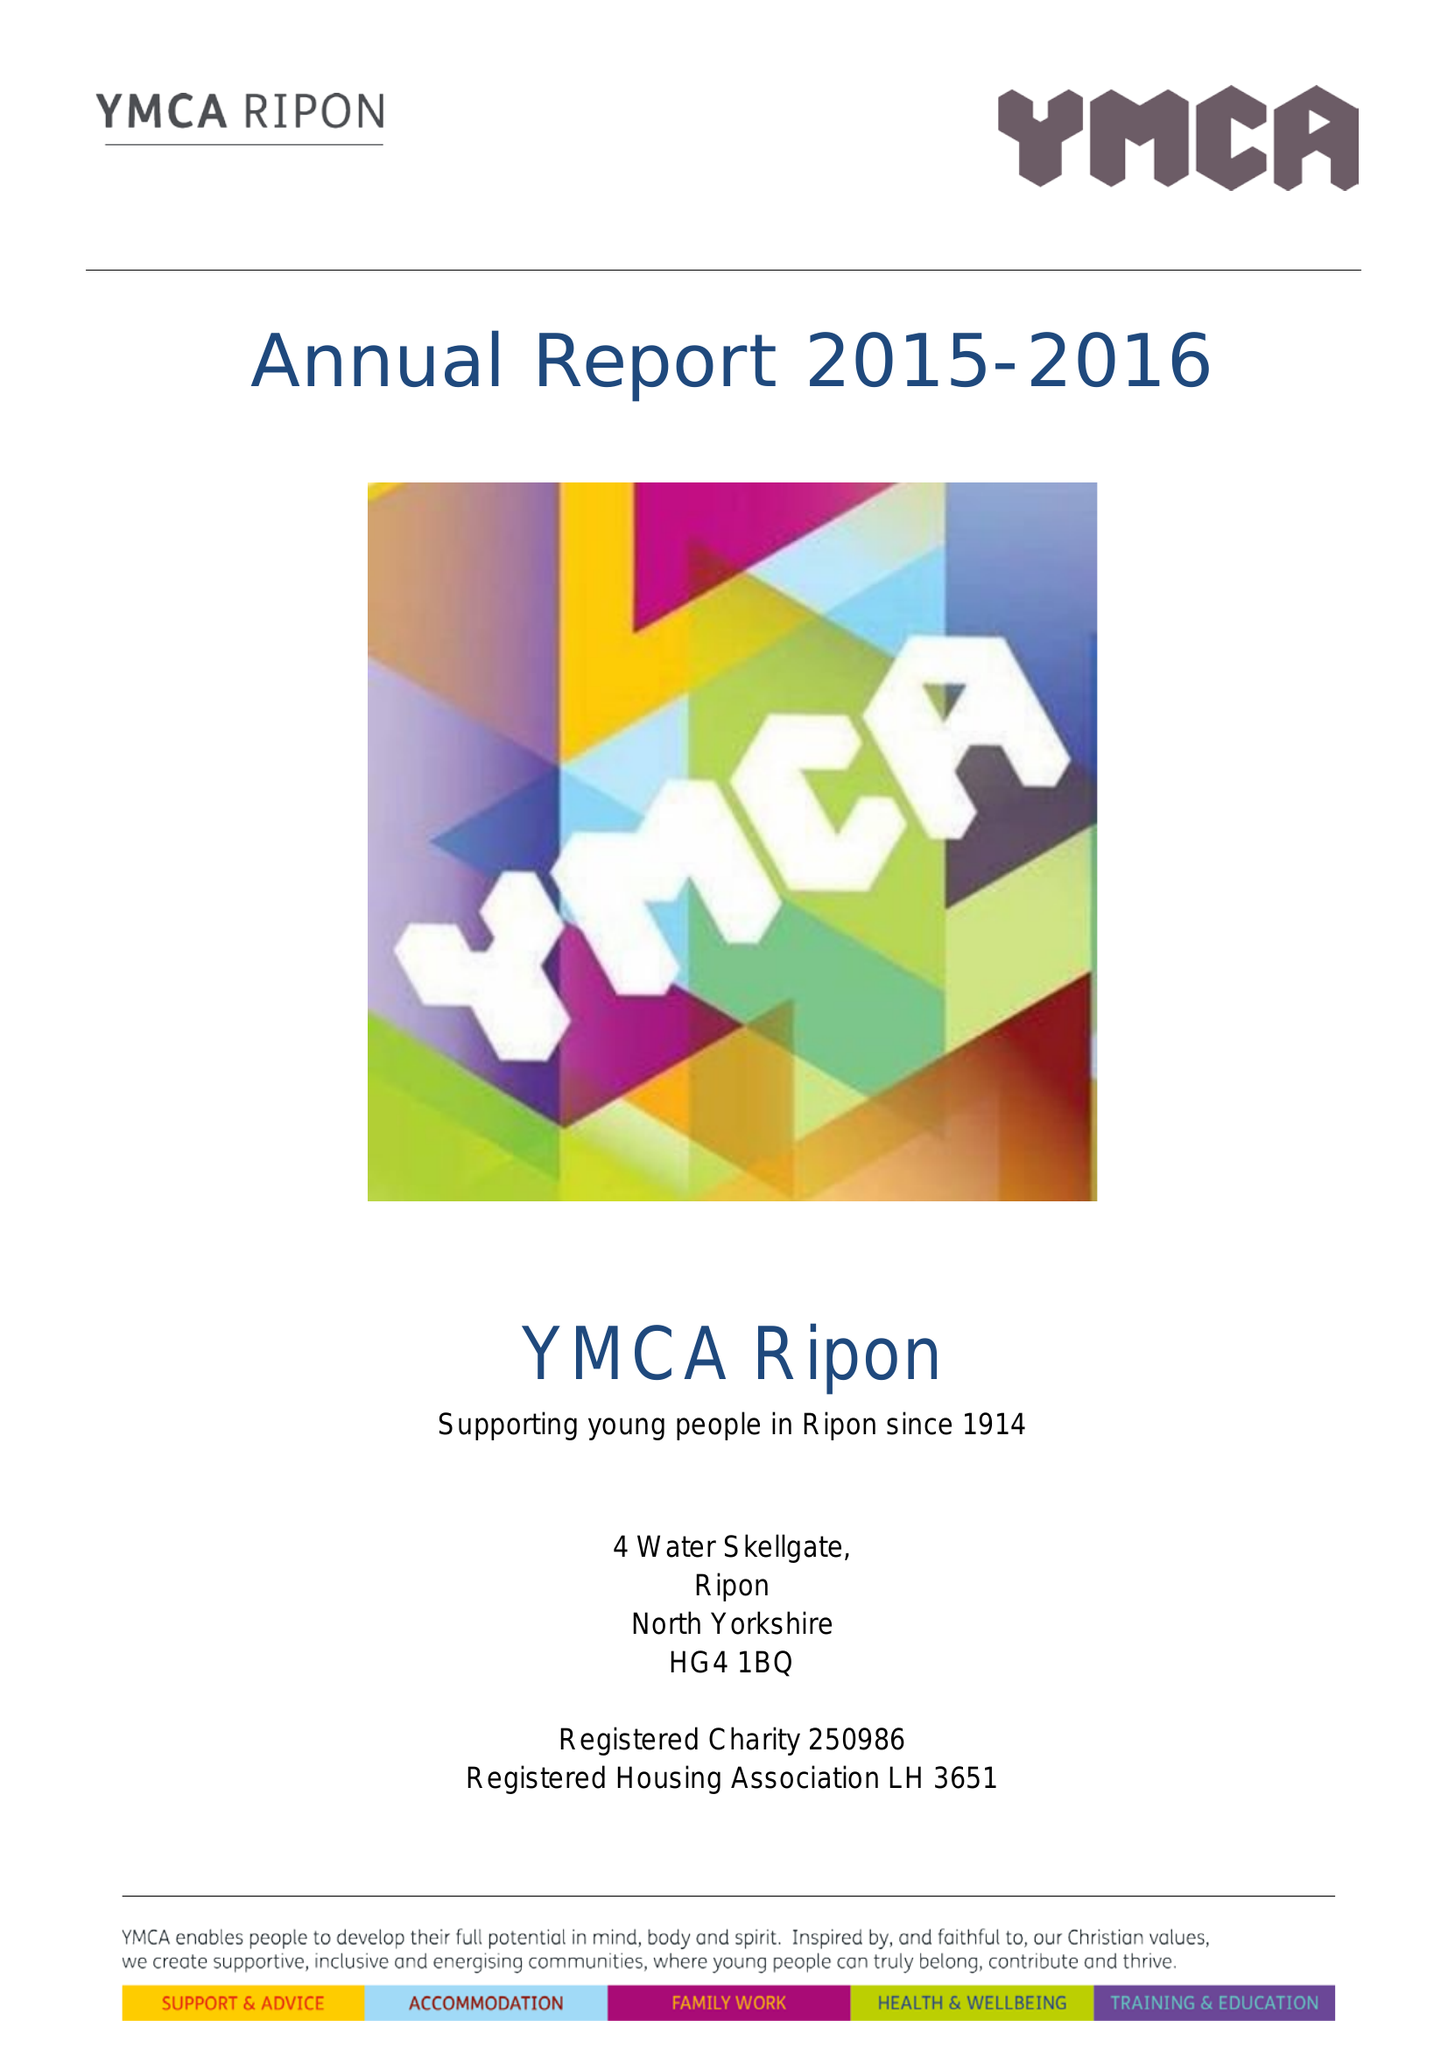What is the value for the address__street_line?
Answer the question using a single word or phrase. 4-5 WATER SKELLGATE 